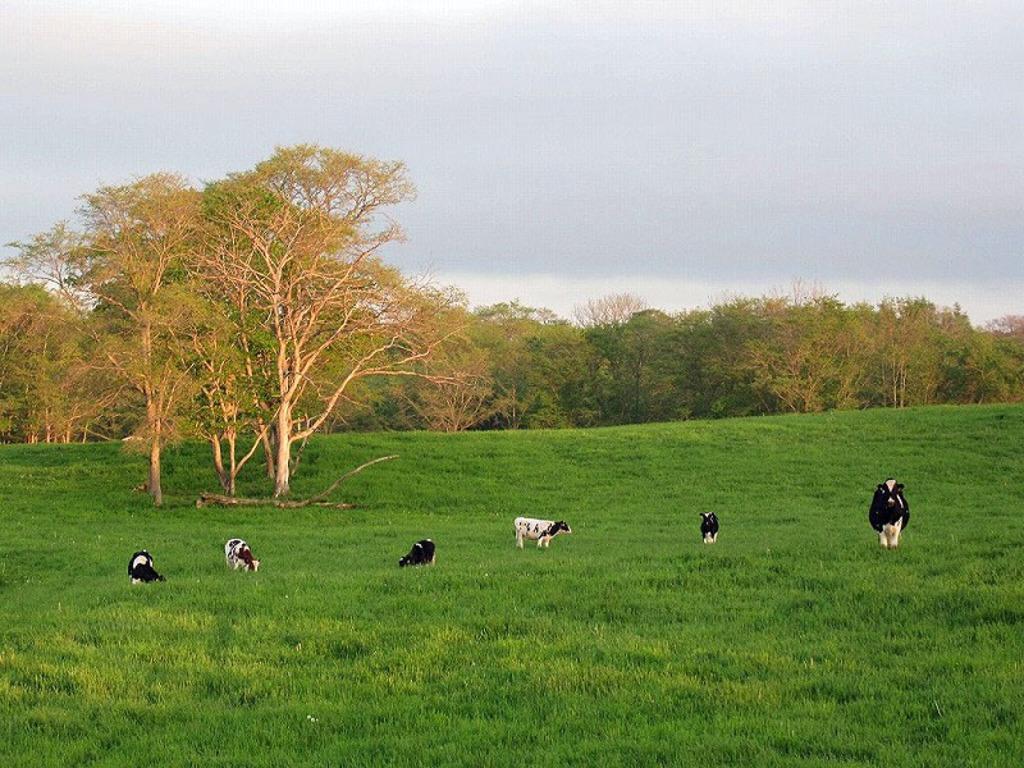Please provide a concise description of this image. In this image there are cows. Behind the cows there is a branch of a tree. At the bottom of the image there is grass on the surface. In the background of the image there are trees and sky. 